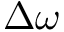<formula> <loc_0><loc_0><loc_500><loc_500>\Delta \omega</formula> 